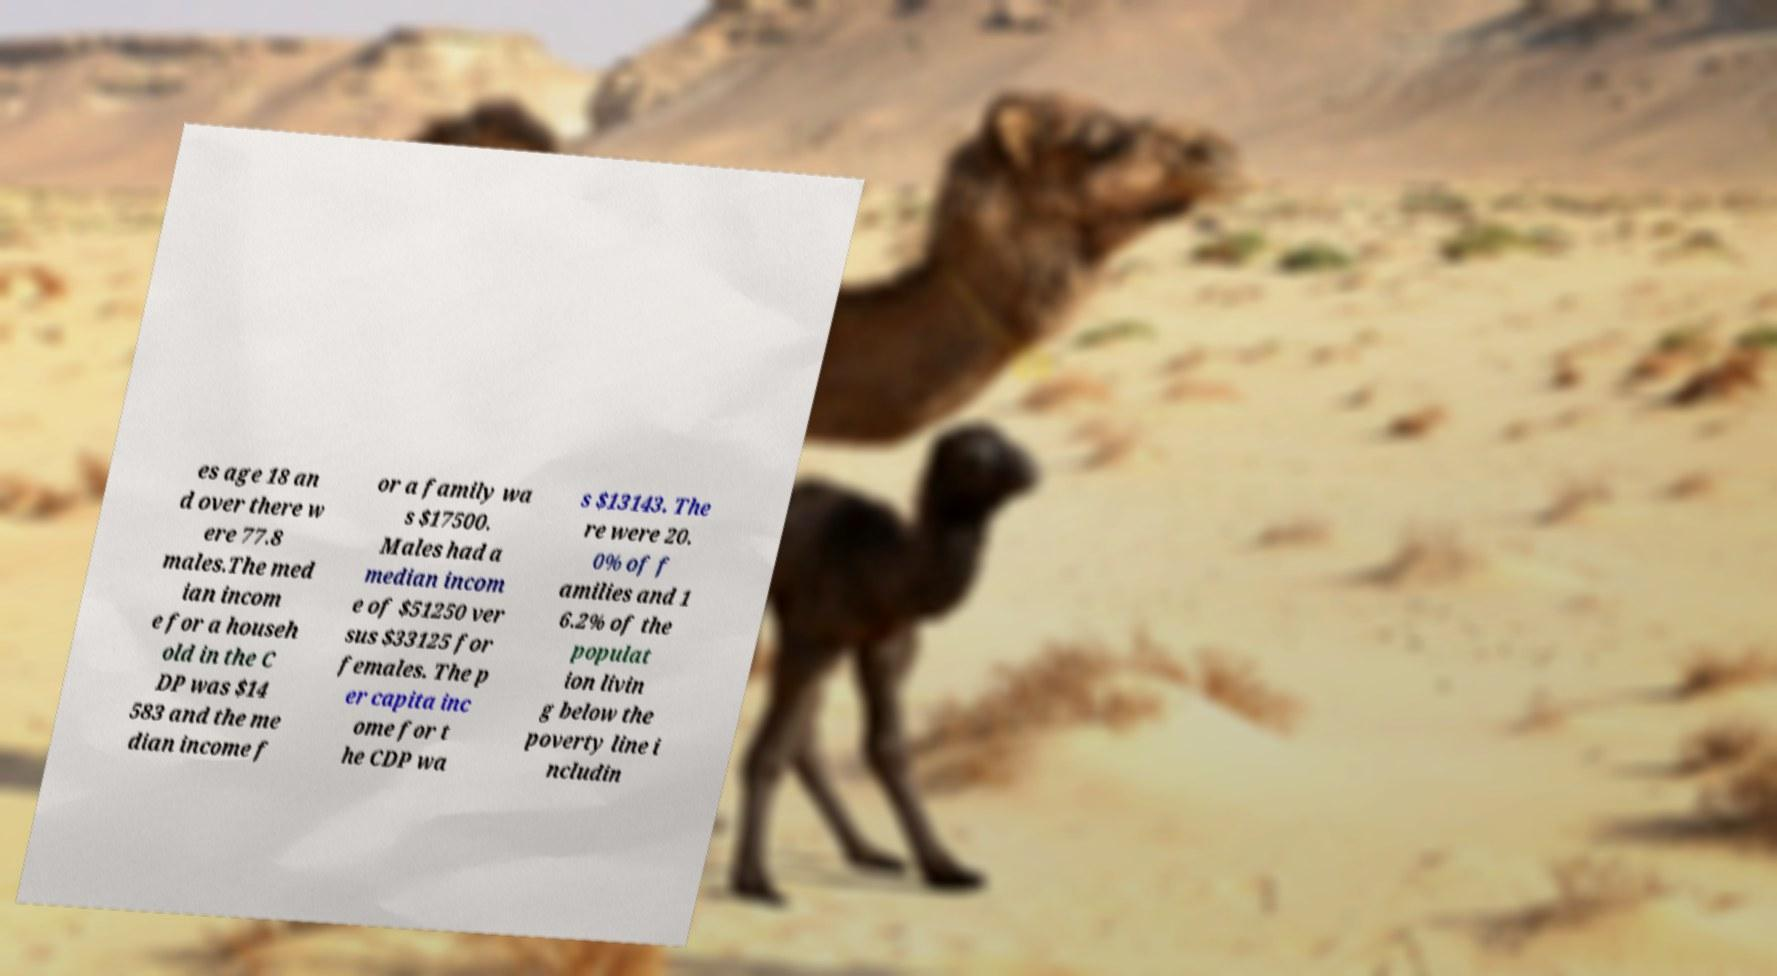I need the written content from this picture converted into text. Can you do that? es age 18 an d over there w ere 77.8 males.The med ian incom e for a househ old in the C DP was $14 583 and the me dian income f or a family wa s $17500. Males had a median incom e of $51250 ver sus $33125 for females. The p er capita inc ome for t he CDP wa s $13143. The re were 20. 0% of f amilies and 1 6.2% of the populat ion livin g below the poverty line i ncludin 